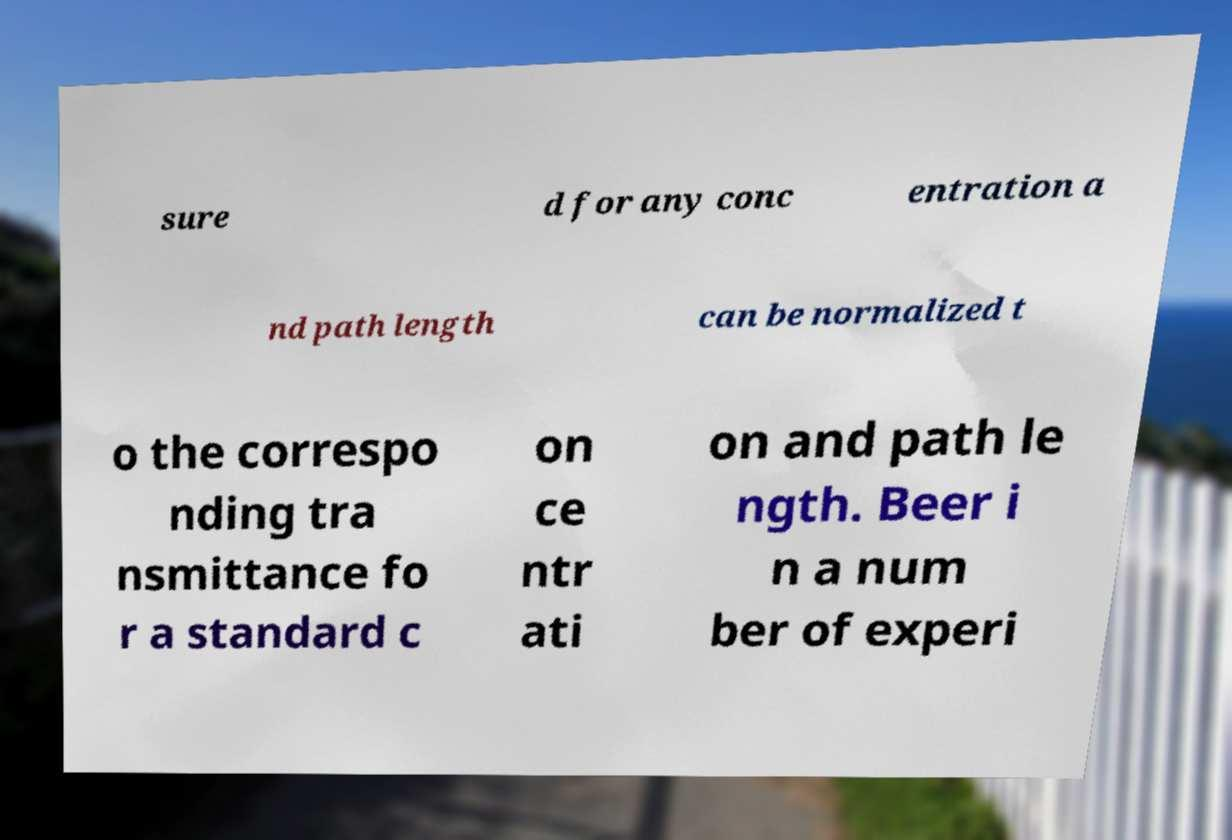Could you assist in decoding the text presented in this image and type it out clearly? sure d for any conc entration a nd path length can be normalized t o the correspo nding tra nsmittance fo r a standard c on ce ntr ati on and path le ngth. Beer i n a num ber of experi 